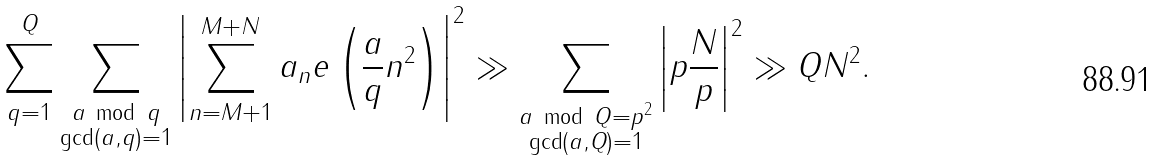<formula> <loc_0><loc_0><loc_500><loc_500>\sum _ { q = 1 } ^ { Q } \sum _ { \substack { a \, \bmod { \, q } \\ \gcd ( a , q ) = 1 } } \left | \sum _ { n = M + 1 } ^ { M + N } a _ { n } e \left ( \frac { a } { q } n ^ { 2 } \right ) \right | ^ { 2 } \gg \sum _ { \substack { a \, \bmod { \, Q = p ^ { 2 } } \\ \gcd ( a , Q ) = 1 } } \left | p \frac { N } { p } \right | ^ { 2 } \gg Q N ^ { 2 } .</formula> 